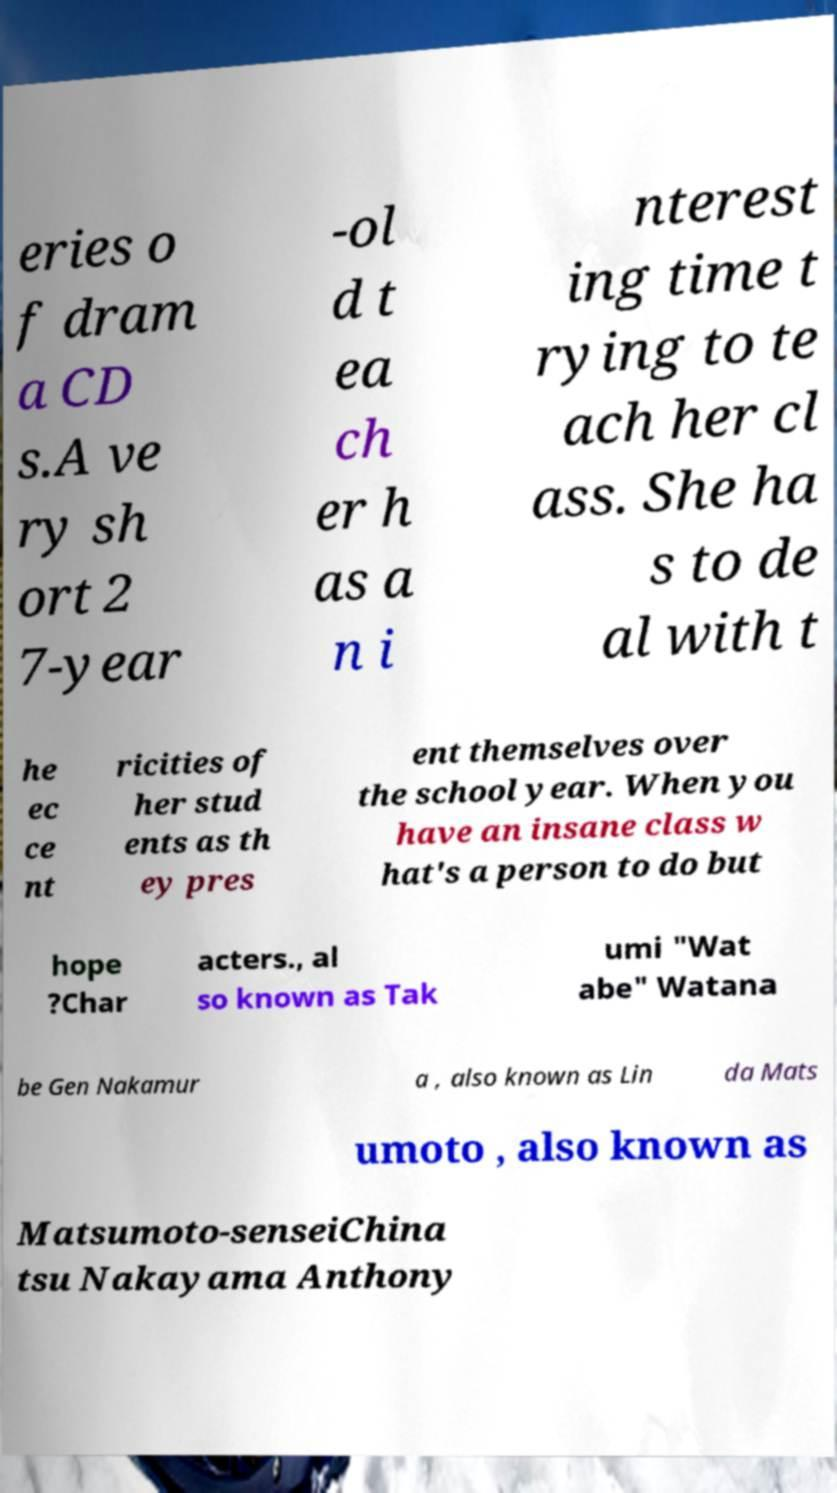Could you extract and type out the text from this image? eries o f dram a CD s.A ve ry sh ort 2 7-year -ol d t ea ch er h as a n i nterest ing time t rying to te ach her cl ass. She ha s to de al with t he ec ce nt ricities of her stud ents as th ey pres ent themselves over the school year. When you have an insane class w hat's a person to do but hope ?Char acters., al so known as Tak umi "Wat abe" Watana be Gen Nakamur a , also known as Lin da Mats umoto , also known as Matsumoto-senseiChina tsu Nakayama Anthony 